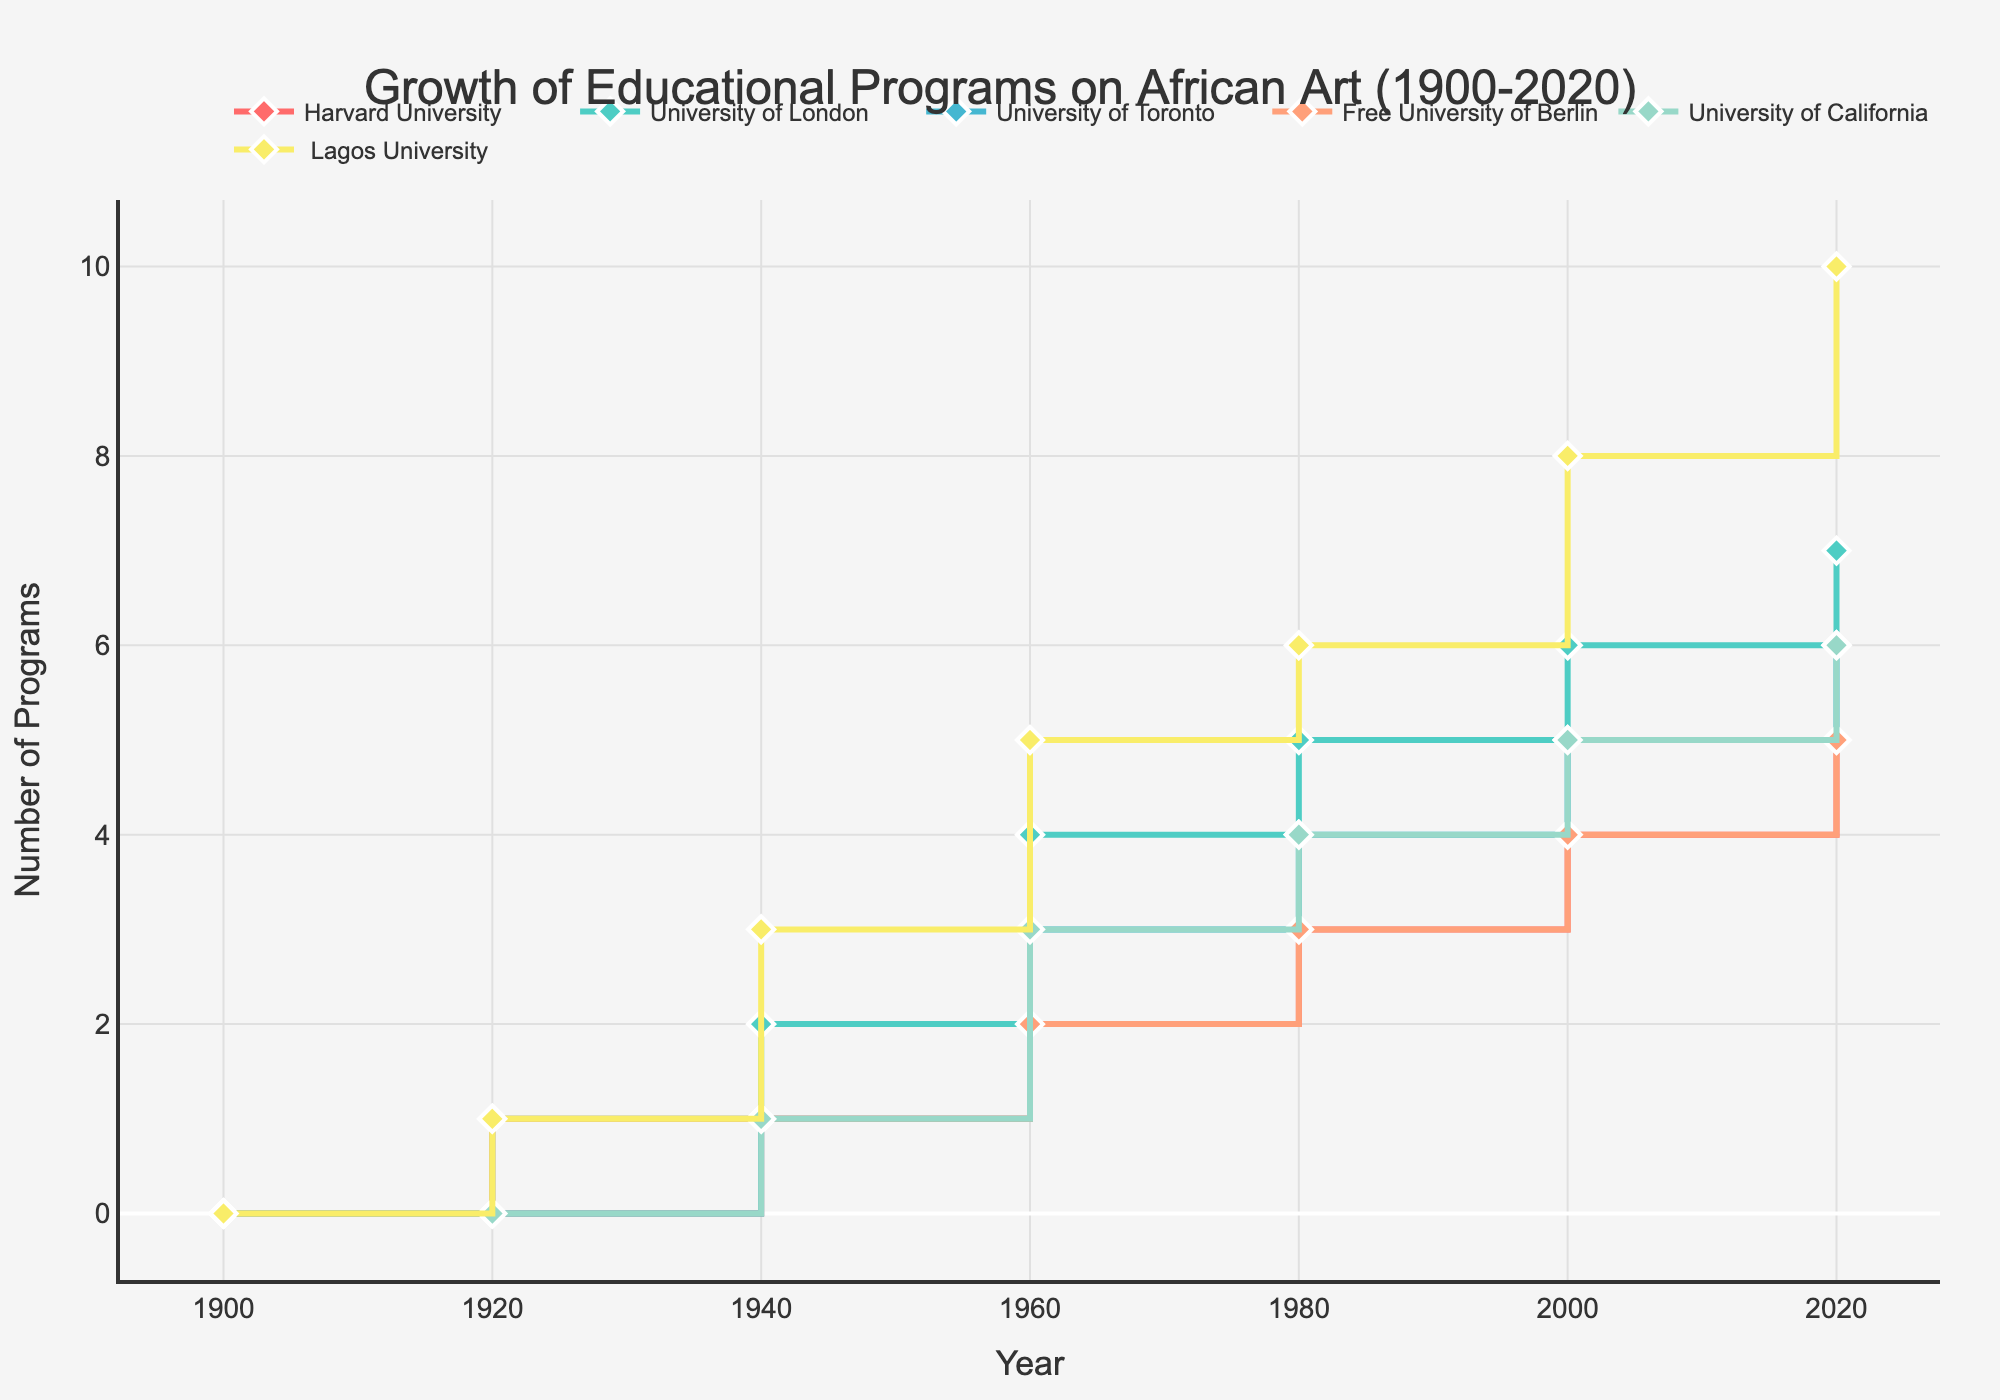what is the title of the figure? The title is displayed at the top center of the figure in a large, bold font. The text reads "Growth of Educational Programs on African Art (1900-2020)."
Answer: Growth of Educational Programs on African Art (1900-2020) how many universities are compared in the figure? The figure includes multiple lines with markers, each representing a different university. By counting the number of different colored lines, we find that six universities are being compared.
Answer: six which university had the highest number of programs in 2020? Observe the y-axis values for the year 2020. Lagos University’s line intersects at the highest point, indicating it had the most programs.
Answer: Lagos University what is the number of programs at Harvard University in 1940? Locate the line representing Harvard University, follow it to the year 1940, and check the corresponding y-axis value. The value is 1.
Answer: 1 by how many programs did the number of programs at the University of London increase from 1980 to 2000? Find the University of London’s line and look at the y-axis values for 1980 and 2000. Subtract the former value (5) from the latter (6) to determine the increase.
Answer: 1 which universities had the same number of programs in 1960? Check the lines at the year 1960. Both the Free University of Berlin and Harvard University have a y-axis value of 2.
Answer: Free University of Berlin and Harvard University among the universities displayed, which one had educational programs the earliest? Identify the point where each university’s line starts. The first educational programs appeared in 1920 at the University of London, the Free University of Berlin, and Lagos University.
Answer: University of London, Free University of Berlin, and Lagos University what is the overall trend in educational programs on African art from 1900 to 2020? Review the general direction of the lines from left to right. Most lines start at 0 and increase over time, indicating a growth trend in educational programs on African art.
Answer: increasing how many total programs were there across all universities in 1940? Sum the number of programs for each university in 1940: Harvard University (1), University of London (2), University of Toronto (1), Free University of Berlin (1), University of California (1), Lagos University (3). The total is 1+2+1+1+1+3 = 9.
Answer: 9 